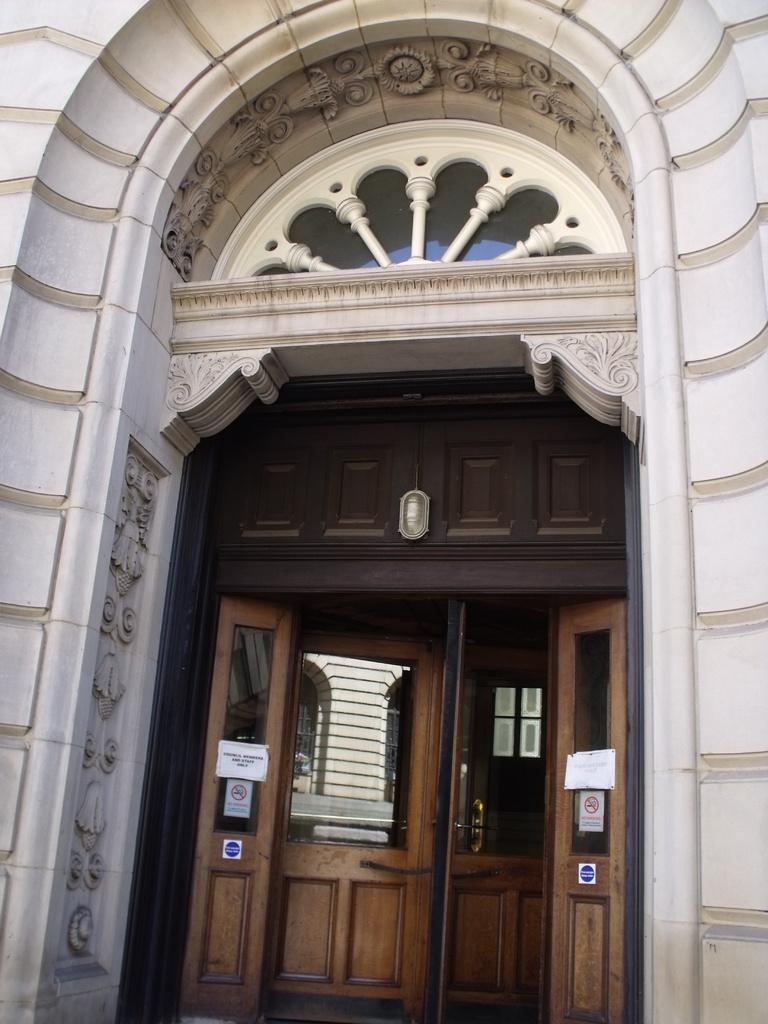What is the main subject in the center of the image? There is a door in the center of the image. What is on the door? There are posters on the door. What architectural feature is above the door? There is an arch above the door. What type of cable can be seen running through the door in the image? There is no cable visible running through the door in the image. 